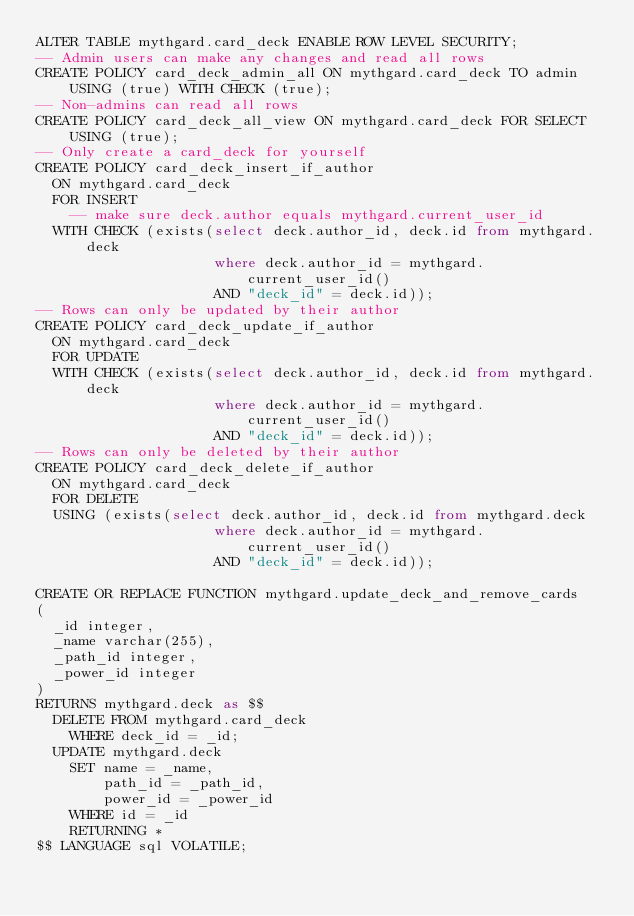Convert code to text. <code><loc_0><loc_0><loc_500><loc_500><_SQL_>ALTER TABLE mythgard.card_deck ENABLE ROW LEVEL SECURITY;
-- Admin users can make any changes and read all rows
CREATE POLICY card_deck_admin_all ON mythgard.card_deck TO admin USING (true) WITH CHECK (true);
-- Non-admins can read all rows
CREATE POLICY card_deck_all_view ON mythgard.card_deck FOR SELECT USING (true);
-- Only create a card_deck for yourself
CREATE POLICY card_deck_insert_if_author
  ON mythgard.card_deck
  FOR INSERT
    -- make sure deck.author equals mythgard.current_user_id
  WITH CHECK (exists(select deck.author_id, deck.id from mythgard.deck
                     where deck.author_id = mythgard.current_user_id()
                     AND "deck_id" = deck.id));
-- Rows can only be updated by their author
CREATE POLICY card_deck_update_if_author
  ON mythgard.card_deck
  FOR UPDATE
  WITH CHECK (exists(select deck.author_id, deck.id from mythgard.deck
                     where deck.author_id = mythgard.current_user_id()
                     AND "deck_id" = deck.id));
-- Rows can only be deleted by their author
CREATE POLICY card_deck_delete_if_author
  ON mythgard.card_deck
  FOR DELETE
  USING (exists(select deck.author_id, deck.id from mythgard.deck
                     where deck.author_id = mythgard.current_user_id()
                     AND "deck_id" = deck.id));

CREATE OR REPLACE FUNCTION mythgard.update_deck_and_remove_cards
(
  _id integer,
  _name varchar(255),
  _path_id integer,
  _power_id integer
)
RETURNS mythgard.deck as $$
  DELETE FROM mythgard.card_deck
    WHERE deck_id = _id;
  UPDATE mythgard.deck
    SET name = _name,
        path_id = _path_id,
        power_id = _power_id
    WHERE id = _id
    RETURNING *
$$ LANGUAGE sql VOLATILE;

</code> 